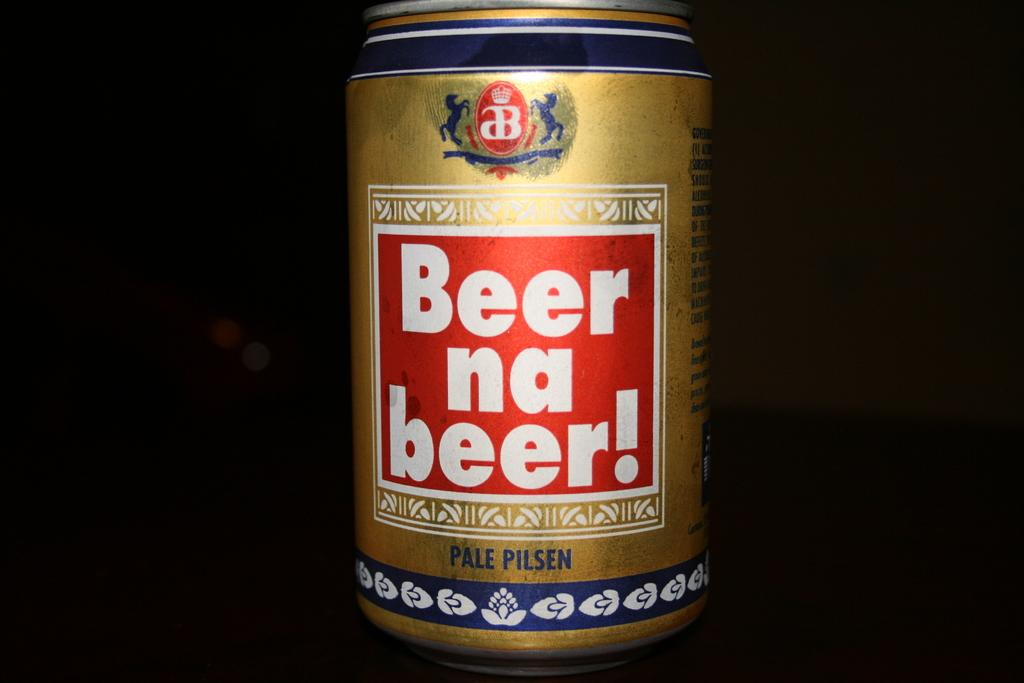<image>
Offer a succinct explanation of the picture presented. A can which has the word Beer on it in white letters. 